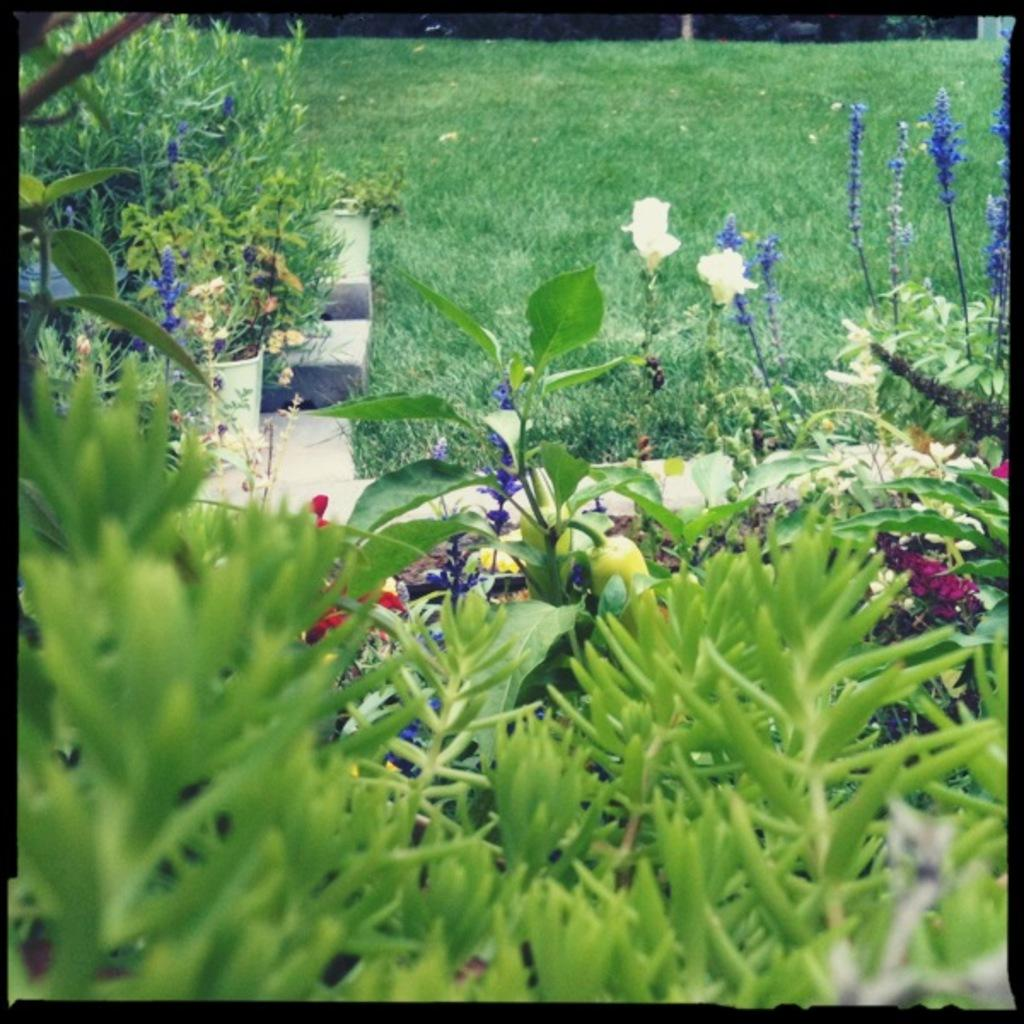What type of vegetation can be seen in the image? There are plants and flowers in the image. What is the ground covered with in the image? There is grass in the image. What invention is being demonstrated in the image? There is no invention being demonstrated in the image; it features plants, flowers, and grass. Is there a sink visible in the image? There is no sink present in the image. 